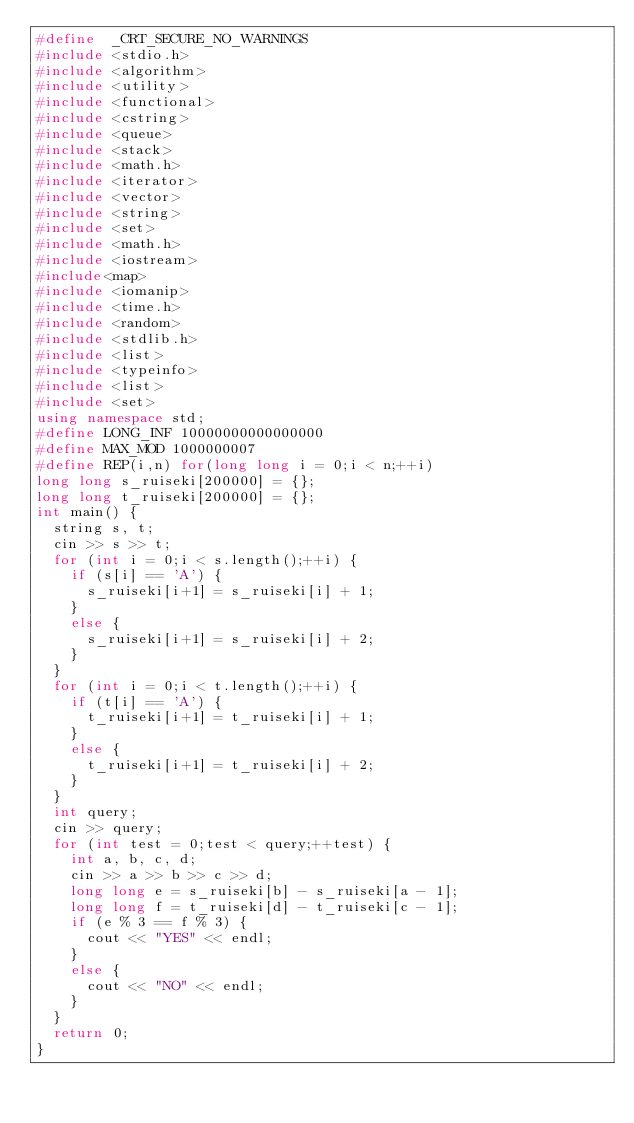<code> <loc_0><loc_0><loc_500><loc_500><_C++_>#define  _CRT_SECURE_NO_WARNINGS
#include <stdio.h>
#include <algorithm>
#include <utility>
#include <functional>
#include <cstring>
#include <queue>
#include <stack>
#include <math.h>
#include <iterator>
#include <vector>
#include <string>
#include <set>
#include <math.h>
#include <iostream> 
#include<map>
#include <iomanip>
#include <time.h>
#include <random>
#include <stdlib.h>
#include <list>
#include <typeinfo>
#include <list>
#include <set>
using namespace std;
#define LONG_INF 10000000000000000
#define MAX_MOD 1000000007
#define REP(i,n) for(long long i = 0;i < n;++i)
long long s_ruiseki[200000] = {};
long long t_ruiseki[200000] = {};
int main() {
	string s, t;
	cin >> s >> t;
	for (int i = 0;i < s.length();++i) {
		if (s[i] == 'A') {
			s_ruiseki[i+1] = s_ruiseki[i] + 1;
		}
		else {
			s_ruiseki[i+1] = s_ruiseki[i] + 2;
		}
	}
	for (int i = 0;i < t.length();++i) {
		if (t[i] == 'A') {
			t_ruiseki[i+1] = t_ruiseki[i] + 1;
		}
		else {
			t_ruiseki[i+1] = t_ruiseki[i] + 2;
		}
	}
	int query;
	cin >> query;
	for (int test = 0;test < query;++test) {
		int a, b, c, d;
		cin >> a >> b >> c >> d;
		long long e = s_ruiseki[b] - s_ruiseki[a - 1];
		long long f = t_ruiseki[d] - t_ruiseki[c - 1];
		if (e % 3 == f % 3) {
			cout << "YES" << endl;
		}
		else {
			cout << "NO" << endl;
		}
	}
	return 0;
}</code> 